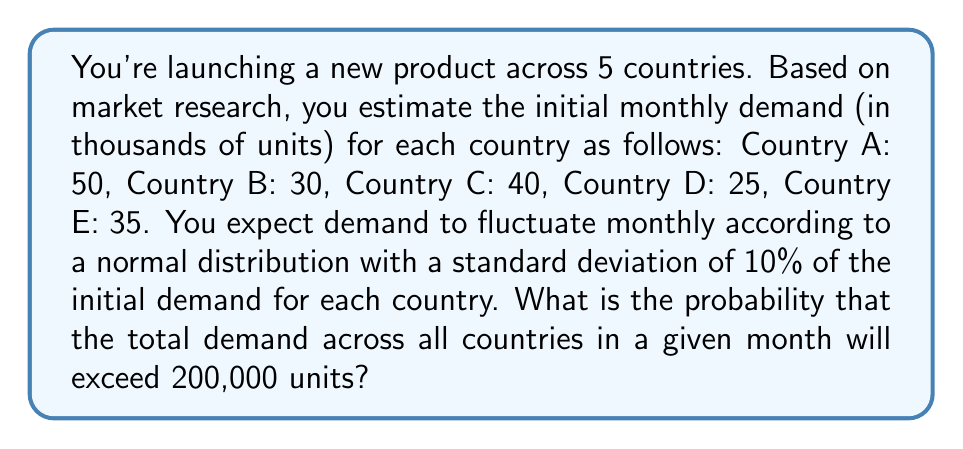Can you answer this question? Let's approach this step-by-step:

1) First, we need to calculate the mean and variance of the total demand:

   Mean (μ) = 50 + 30 + 40 + 25 + 35 = 180 thousand units

2) For the variance, we need to sum the variances of each country:
   Variance for each country = (SD)^2 = (0.1 * initial demand)^2

   Country A: $Var_A = (0.1 * 50)^2 = 25$
   Country B: $Var_B = (0.1 * 30)^2 = 9$
   Country C: $Var_C = (0.1 * 40)^2 = 16$
   Country D: $Var_D = (0.1 * 25)^2 = 6.25$
   Country E: $Var_E = (0.1 * 35)^2 = 12.25$

   Total variance = 25 + 9 + 16 + 6.25 + 12.25 = 68.5

3) The standard deviation of the total demand:
   $SD = \sqrt{68.5} \approx 8.28$ thousand units

4) We want to find P(X > 200), where X is the total demand

5) Standardizing the normal distribution:
   $Z = \frac{X - \mu}{SD} = \frac{200 - 180}{8.28} \approx 2.42$

6) We need to find P(Z > 2.42)

7) Using a standard normal distribution table or calculator:
   P(Z > 2.42) ≈ 0.0078

Therefore, the probability that the total demand will exceed 200,000 units is approximately 0.0078 or 0.78%.
Answer: 0.0078 